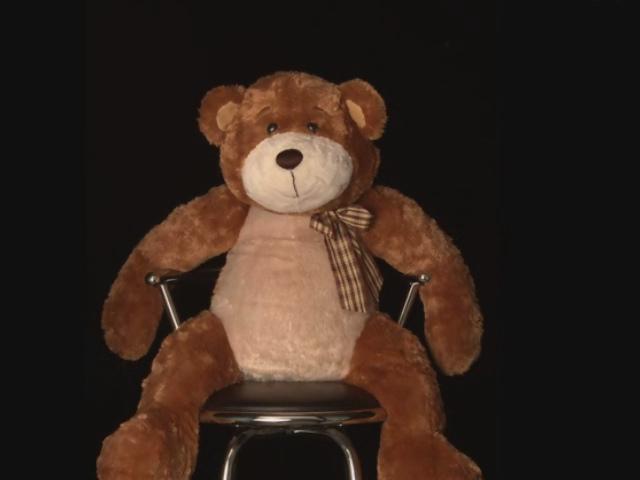What color is the teddy bear?
Short answer required. Brown. Is the teddy bear big?
Give a very brief answer. Yes. What pattern is on the ribbon?
Quick response, please. Plaid. 